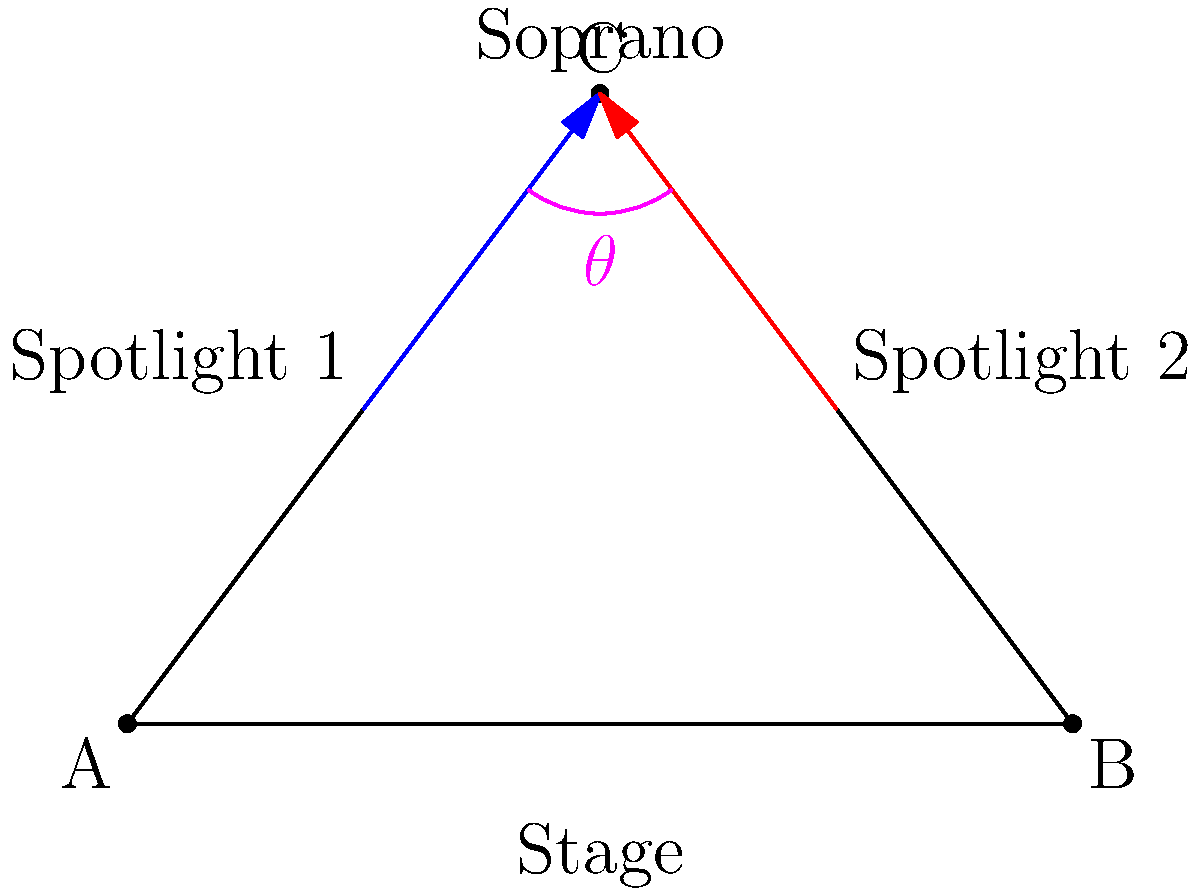At the Warsaw Opera House, a renowned Polish coloratura soprano is performing a challenging aria from Bellini's "I Puritani". Two spotlights illuminate her from different angles on stage. Spotlight 1 is positioned 4.5 meters from the soprano and creates a 60° angle with the stage floor. Spotlight 2 is positioned 3.5 meters from the soprano and creates a 45° angle with the stage floor. What is the angle $\theta$ between the two spotlights? Let's solve this step-by-step using the law of cosines:

1) First, we need to visualize the problem in 3D space. The soprano and the two spotlights form a triangle in 3D.

2) Let's call the position of the soprano point C, and the positions of Spotlight 1 and Spotlight 2 as points A and B respectively.

3) We know:
   AC = 4.5 m (distance from Spotlight 1 to soprano)
   BC = 3.5 m (distance from Spotlight 2 to soprano)
   Angle between AC and the stage = 60°
   Angle between BC and the stage = 45°

4) We need to find the third side of the triangle (AB) to use the law of cosines.

5) The vertical heights of the spotlights:
   Height of A = 4.5 * sin(60°) = 3.897 m
   Height of B = 3.5 * sin(45°) = 2.475 m

6) The horizontal distances from the soprano:
   For A: 4.5 * cos(60°) = 2.25 m
   For B: 3.5 * cos(45°) = 2.475 m

7) The horizontal distance between the spotlights:
   2.25 + 2.475 = 4.725 m

8) Now we can find AB using the Pythagorean theorem:
   $AB = \sqrt{4.725^2 + (3.897 - 2.475)^2} = 4.986$ m

9) Now we have all sides of the triangle:
   AC = 4.5 m
   BC = 3.5 m
   AB = 4.986 m

10) We can use the law of cosines to find angle $\theta$:
    $\cos(\theta) = \frac{AC^2 + BC^2 - AB^2}{2(AC)(BC)}$

11) Substituting the values:
    $\cos(\theta) = \frac{4.5^2 + 3.5^2 - 4.986^2}{2(4.5)(3.5)} = 0.3416$

12) Taking the inverse cosine (arccos):
    $\theta = \arccos(0.3416) = 70.0°$

Therefore, the angle between the two spotlights is approximately 70.0°.
Answer: 70.0° 